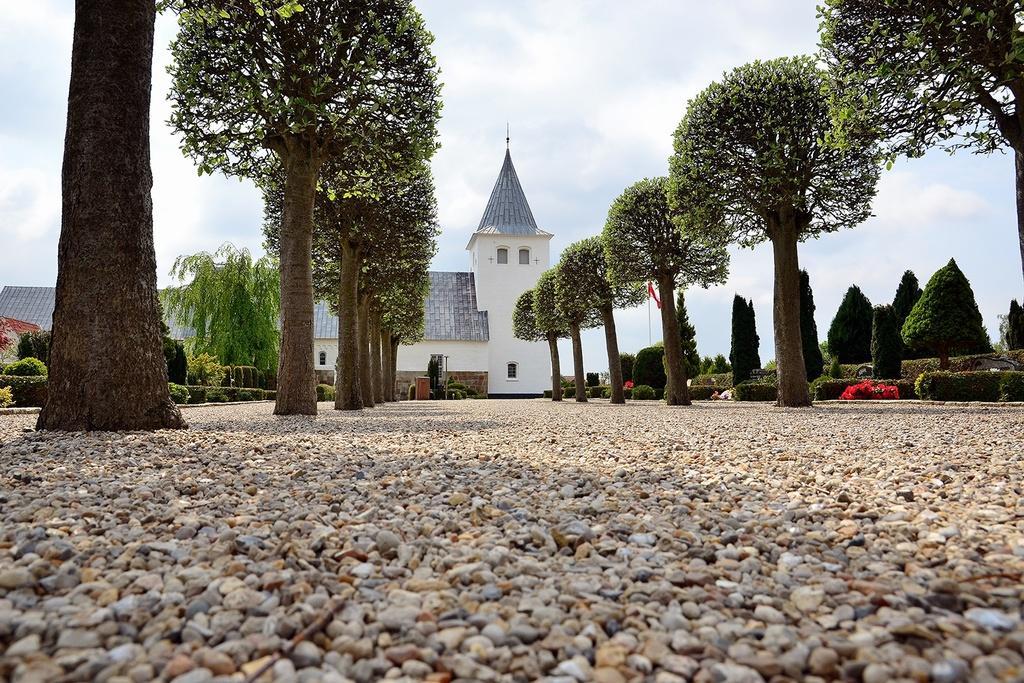How would you summarize this image in a sentence or two? In this image I can see the ground, few small stones on the ground, few trees which are green and brown in color and few flowers which are red in color. In the background I can see a house which is white and blue in color and the sky. 